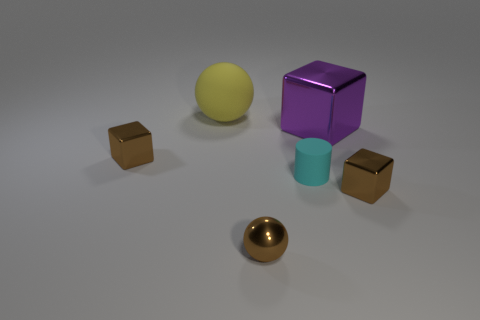Subtract all brown cubes. How many cubes are left? 1 Subtract all purple blocks. How many blocks are left? 2 Add 2 small spheres. How many objects exist? 8 Subtract all cylinders. How many objects are left? 5 Subtract all brown cylinders. Subtract all purple cubes. How many cylinders are left? 1 Subtract all brown blocks. How many yellow balls are left? 1 Subtract all tiny brown objects. Subtract all green spheres. How many objects are left? 3 Add 5 large yellow rubber things. How many large yellow rubber things are left? 6 Add 3 gray cylinders. How many gray cylinders exist? 3 Subtract 0 gray blocks. How many objects are left? 6 